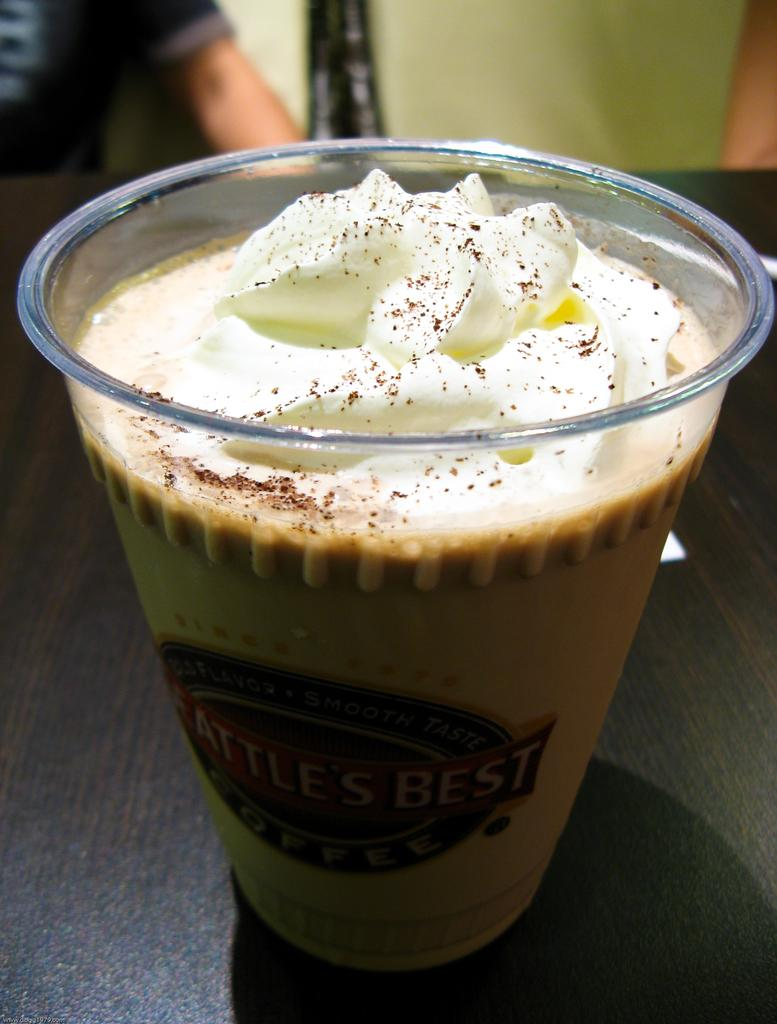What is in the glass that is visible in the image? There is a glass of coffee drink in the image. Where is the glass of coffee drink located? The glass of coffee drink is placed on a table. Can you describe anything else visible in the image? There is a person's hand visible in the background of the image. What type of rice is being served with the coffee drink in the image? There is no rice present in the image; it only features a glass of coffee drink and a person's hand in the background. 